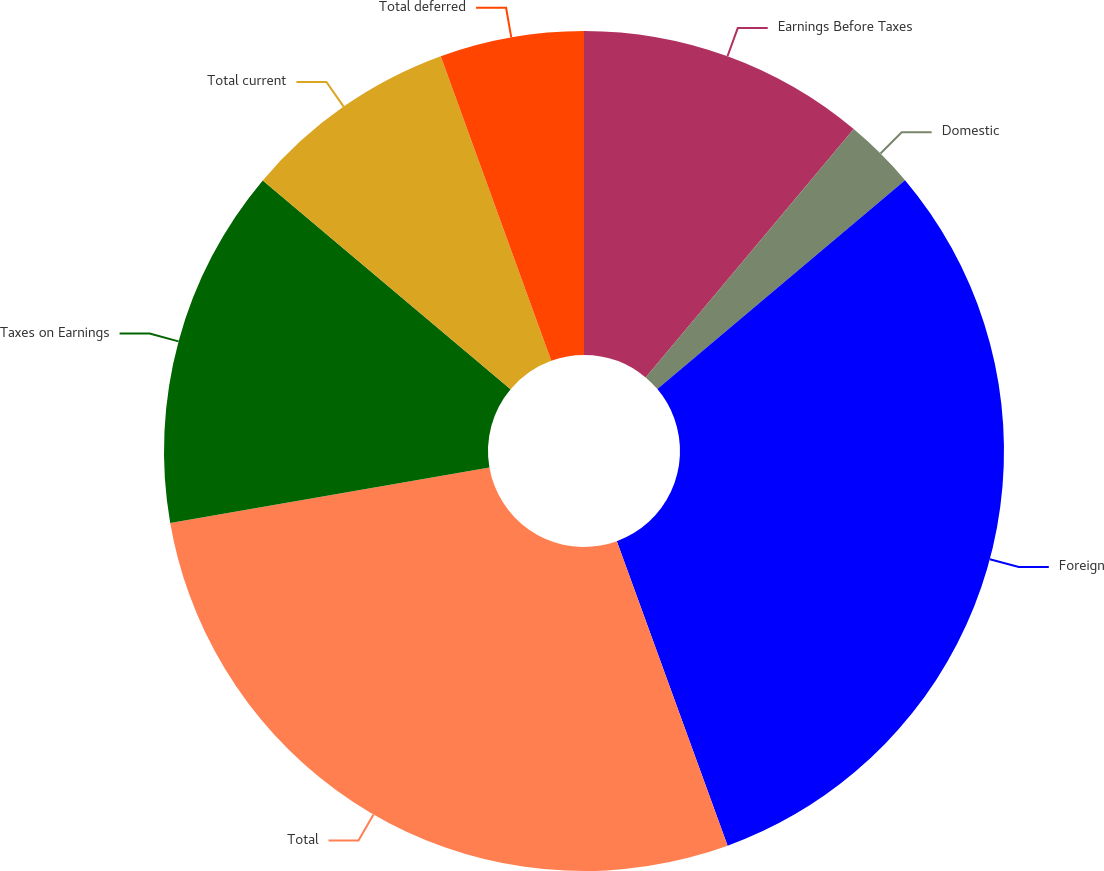<chart> <loc_0><loc_0><loc_500><loc_500><pie_chart><fcel>Earnings Before Taxes<fcel>Domestic<fcel>Foreign<fcel>Total<fcel>Taxes on Earnings<fcel>Total current<fcel>Total deferred<nl><fcel>11.1%<fcel>2.75%<fcel>30.6%<fcel>27.82%<fcel>13.88%<fcel>8.32%<fcel>5.54%<nl></chart> 